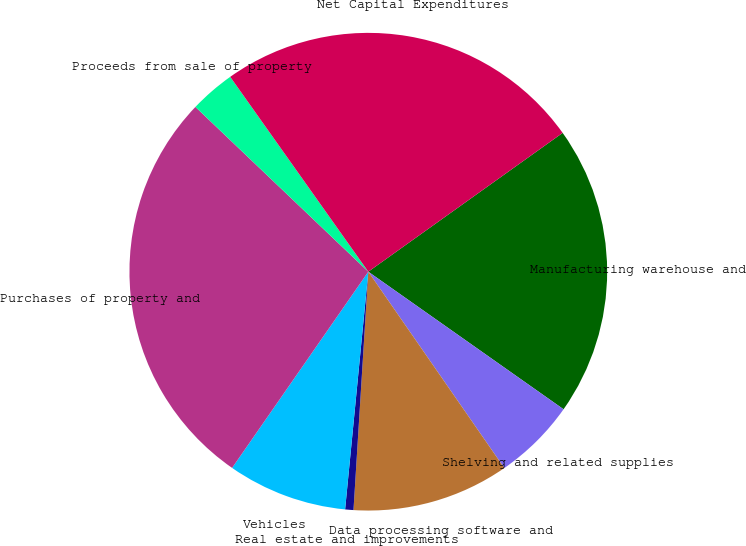Convert chart to OTSL. <chart><loc_0><loc_0><loc_500><loc_500><pie_chart><fcel>Manufacturing warehouse and<fcel>Shelving and related supplies<fcel>Data processing software and<fcel>Real estate and improvements<fcel>Vehicles<fcel>Purchases of property and<fcel>Proceeds from sale of property<fcel>Net Capital Expenditures<nl><fcel>19.64%<fcel>5.59%<fcel>10.63%<fcel>0.56%<fcel>8.11%<fcel>27.46%<fcel>3.07%<fcel>24.94%<nl></chart> 